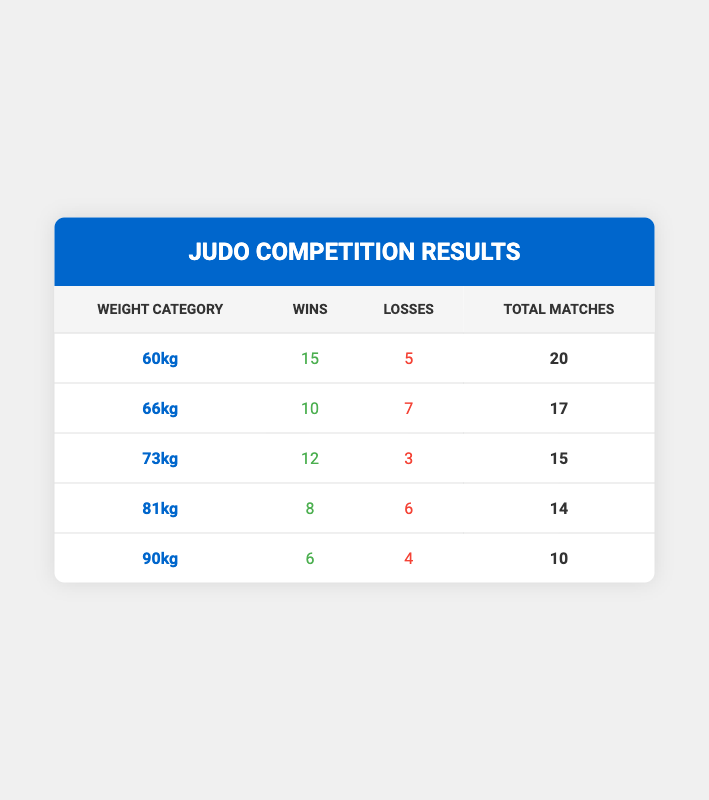What is the total number of wins in the 60kg category? The table indicates that the number of wins in the 60kg category is 15.
Answer: 15 What is the total number of losses in the 66kg category? The table indicates that the number of losses in the 66kg category is 7.
Answer: 7 In which weight category did the athlete achieve the most wins? By comparing the wins across all categories, 60kg has the highest wins at 15.
Answer: 60kg What is the total number of matches for the 73kg category? The table indicates that the total matches in the 73kg category is 15 (12 wins + 3 losses).
Answer: 15 Is it true that the athlete had more losses than wins in the 90kg category? For the 90kg category, the athlete has 6 wins and 4 losses, meaning they had more wins, so the statement is false.
Answer: No What is the average number of wins across all categories? To find the average, sum the wins (15 + 10 + 12 + 8 + 6 = 51) and divide by the number of categories (5), resulting in 51/5 = 10.2.
Answer: 10.2 How many more wins did the athlete have in the 60kg category compared to the 81kg category? The athlete had 15 wins in the 60kg category and 8 wins in the 81kg category, so the difference is 15 - 8 = 7.
Answer: 7 Which weight category has the highest win-loss ratio? Calculate the win-loss ratio (wins/losses) for each category. The 73kg category ratio is highest at 12/3 = 4.
Answer: 73kg What is the total number of matches combined for the 81kg and 90kg categories? The total matches for 81kg is 14 and for 90kg is 10, totaling 14 + 10 = 24.
Answer: 24 